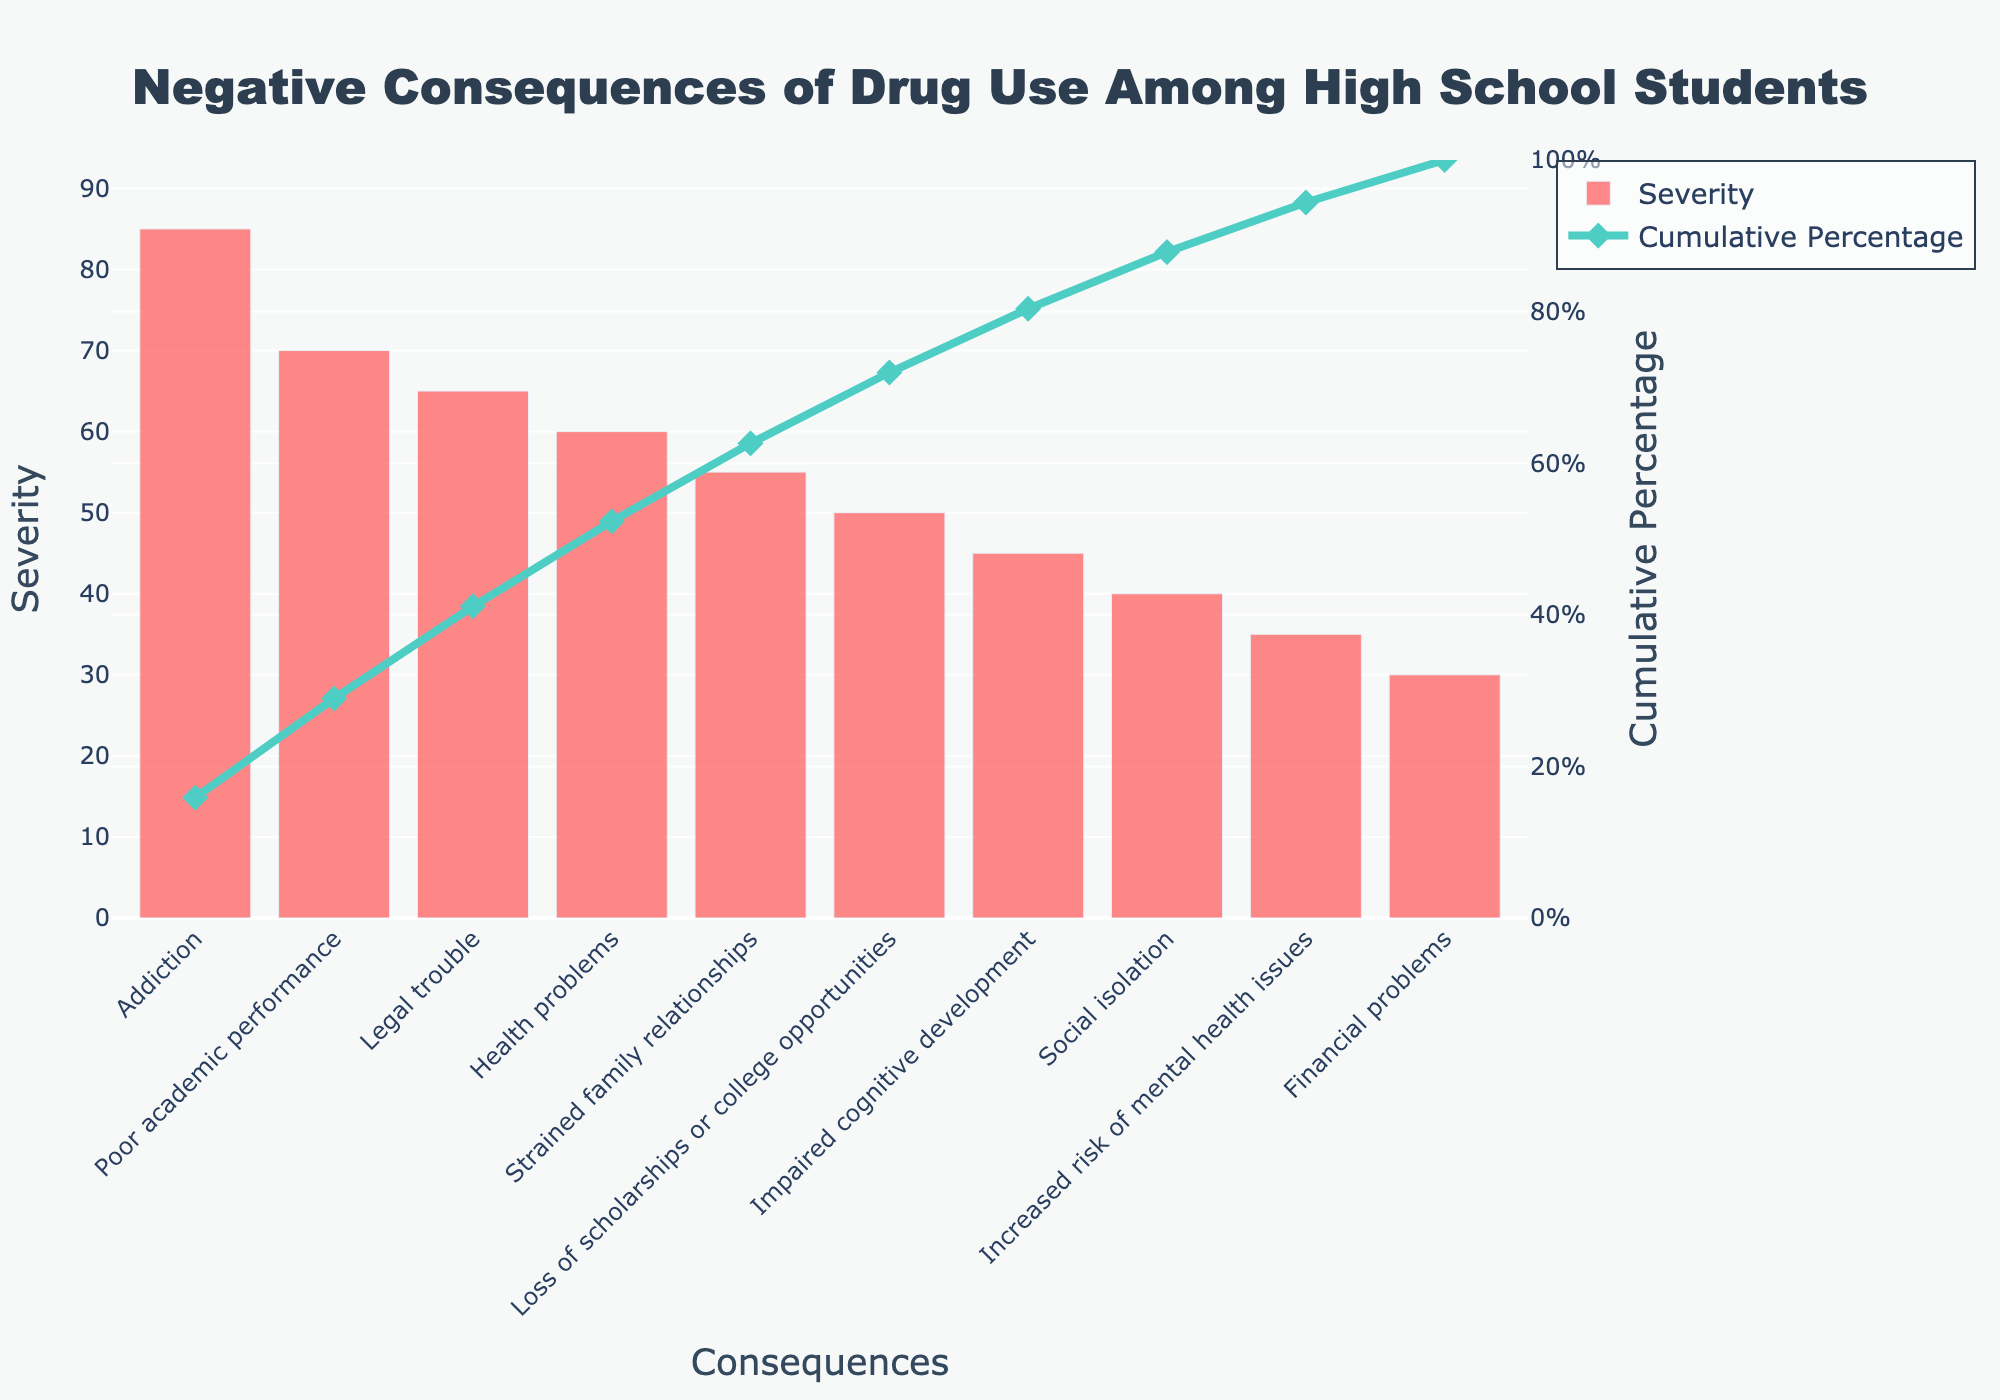What is the title of the figure? The title is usually placed at the top of the figure and provides a brief description of what the chart represents. In this figure, it is "Negative Consequences of Drug Use Among High School Students".
Answer: Negative Consequences of Drug Use Among High School Students Which consequence is the most severe according to the chart? The chart ranks the consequences by severity, with the most severe consequence having the highest bar and being listed first. In this case, it is "Addiction" with a severity of 85.
Answer: Addiction What is the cumulative percentage of the top three consequences? To find the cumulative percentage of the top three consequences, locate the cumulative percentage line and sum the values at the points of the first three consequences. The cumulative percentages for "Addiction", "Poor academic performance", and "Legal trouble" are approximately 28.73%, 52.87%, and 74.58%, respectively. Adding these gives the cumulative: 28.73% + 24.14% + 21.71% = approximately 74.58%.
Answer: 74.58% Which consequence has a severity level closest to 50? By observing the height of the bars and their corresponding severity values, the consequence "Loss of scholarships or college opportunities" has a severity level of 50, which is closest to 50.
Answer: Loss of scholarships or college opportunities Which consequence is less severe than health problems but more severe than impaired cognitive development? Check the severity values that are positioned between the severity of "Health problems" (60) and "Impaired cognitive development" (45). The consequence fitting this criteria is "Strained family relationships" with a severity of 55.
Answer: Strained family relationships What cumulative percentage does the consequence "Strained family relationships" contribute to? To find this, locate the point on the cumulative percentage line that corresponds to "Strained family relationships." This point shows approximately 87.29%.
Answer: 87.29% How many consequences have a severity level greater than 50? Count the bars representing consequences with severity levels higher than 50 from the chart. The consequences are: Addiction, Poor academic performance, Legal trouble, Health problems, and Strained family relationships. This totals to 5.
Answer: 5 Is there any consequence that has a severity of exactly 30? By referring to the bars on the chart and their corresponding severity values, it can be seen that "Financial problems" has a severity of exactly 30.
Answer: Financial problems Which two consequences contribute the least to the cumulative percentage? By identifying the two consequences with the smallest severity values, you find "Financial problems" and "Increased risk of mental health issues" with severities of 30 and 35 respectively.
Answer: Financial problems and Increased risk of mental health issues What is the general trend indicated by the cumulative percentage line in the Pareto chart? The cumulative percentage line generally trends upwards from left to right. This indicates that the cumulative impact of consecutive consequences increases, emphasizing that a small number of consequences contribute to a large portion of the total severity.
Answer: Upwards trend 